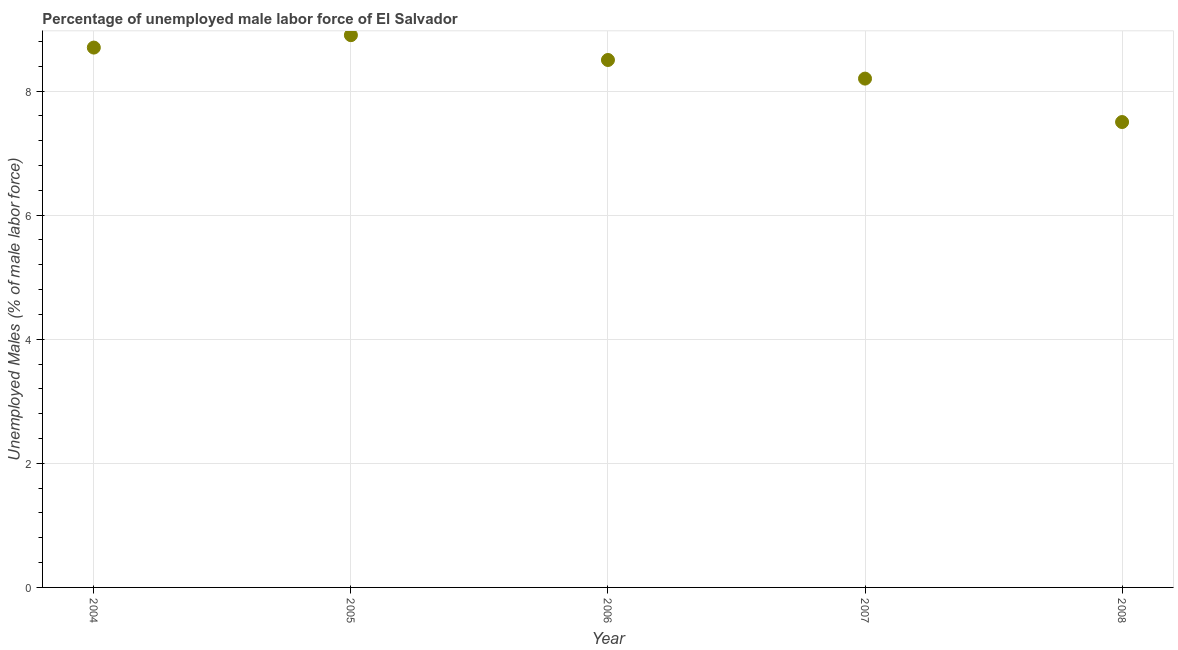What is the total unemployed male labour force in 2004?
Make the answer very short. 8.7. Across all years, what is the maximum total unemployed male labour force?
Make the answer very short. 8.9. Across all years, what is the minimum total unemployed male labour force?
Give a very brief answer. 7.5. In which year was the total unemployed male labour force maximum?
Provide a short and direct response. 2005. In which year was the total unemployed male labour force minimum?
Keep it short and to the point. 2008. What is the sum of the total unemployed male labour force?
Provide a short and direct response. 41.8. What is the average total unemployed male labour force per year?
Give a very brief answer. 8.36. What is the median total unemployed male labour force?
Offer a very short reply. 8.5. In how many years, is the total unemployed male labour force greater than 5.2 %?
Offer a very short reply. 5. Do a majority of the years between 2006 and 2004 (inclusive) have total unemployed male labour force greater than 0.4 %?
Make the answer very short. No. What is the ratio of the total unemployed male labour force in 2004 to that in 2007?
Your answer should be very brief. 1.06. Is the total unemployed male labour force in 2007 less than that in 2008?
Offer a very short reply. No. What is the difference between the highest and the second highest total unemployed male labour force?
Provide a short and direct response. 0.2. Is the sum of the total unemployed male labour force in 2005 and 2007 greater than the maximum total unemployed male labour force across all years?
Offer a terse response. Yes. What is the difference between the highest and the lowest total unemployed male labour force?
Ensure brevity in your answer.  1.4. Does the total unemployed male labour force monotonically increase over the years?
Keep it short and to the point. No. How many dotlines are there?
Offer a very short reply. 1. How many years are there in the graph?
Your response must be concise. 5. What is the difference between two consecutive major ticks on the Y-axis?
Make the answer very short. 2. Are the values on the major ticks of Y-axis written in scientific E-notation?
Provide a succinct answer. No. Does the graph contain any zero values?
Your answer should be very brief. No. Does the graph contain grids?
Offer a terse response. Yes. What is the title of the graph?
Offer a very short reply. Percentage of unemployed male labor force of El Salvador. What is the label or title of the X-axis?
Make the answer very short. Year. What is the label or title of the Y-axis?
Your response must be concise. Unemployed Males (% of male labor force). What is the Unemployed Males (% of male labor force) in 2004?
Make the answer very short. 8.7. What is the Unemployed Males (% of male labor force) in 2005?
Your answer should be very brief. 8.9. What is the Unemployed Males (% of male labor force) in 2006?
Provide a succinct answer. 8.5. What is the Unemployed Males (% of male labor force) in 2007?
Keep it short and to the point. 8.2. What is the difference between the Unemployed Males (% of male labor force) in 2004 and 2005?
Keep it short and to the point. -0.2. What is the difference between the Unemployed Males (% of male labor force) in 2004 and 2008?
Your answer should be very brief. 1.2. What is the difference between the Unemployed Males (% of male labor force) in 2005 and 2006?
Your response must be concise. 0.4. What is the difference between the Unemployed Males (% of male labor force) in 2005 and 2008?
Ensure brevity in your answer.  1.4. What is the difference between the Unemployed Males (% of male labor force) in 2007 and 2008?
Offer a terse response. 0.7. What is the ratio of the Unemployed Males (% of male labor force) in 2004 to that in 2005?
Offer a terse response. 0.98. What is the ratio of the Unemployed Males (% of male labor force) in 2004 to that in 2006?
Your answer should be very brief. 1.02. What is the ratio of the Unemployed Males (% of male labor force) in 2004 to that in 2007?
Provide a short and direct response. 1.06. What is the ratio of the Unemployed Males (% of male labor force) in 2004 to that in 2008?
Make the answer very short. 1.16. What is the ratio of the Unemployed Males (% of male labor force) in 2005 to that in 2006?
Ensure brevity in your answer.  1.05. What is the ratio of the Unemployed Males (% of male labor force) in 2005 to that in 2007?
Provide a succinct answer. 1.08. What is the ratio of the Unemployed Males (% of male labor force) in 2005 to that in 2008?
Offer a very short reply. 1.19. What is the ratio of the Unemployed Males (% of male labor force) in 2006 to that in 2008?
Make the answer very short. 1.13. What is the ratio of the Unemployed Males (% of male labor force) in 2007 to that in 2008?
Your answer should be very brief. 1.09. 